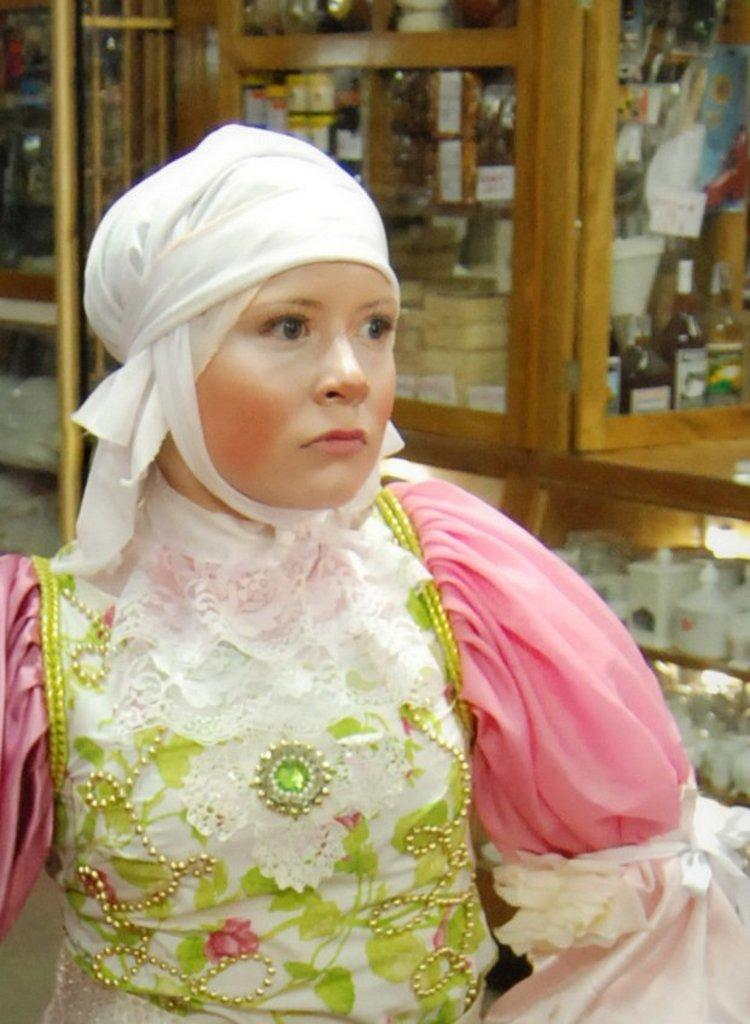Who is present in the image? There is a woman in the image. What is the woman wearing? The woman is wearing a pink dress. What can be seen in the background of the image? There is a wooden glass and white boxes in the racks in the background of the image. How many dimes are scattered on the floor in the image? There are no dimes visible on the floor in the image. Are there any men present in the image? The image only features a woman, and there are no men present. 